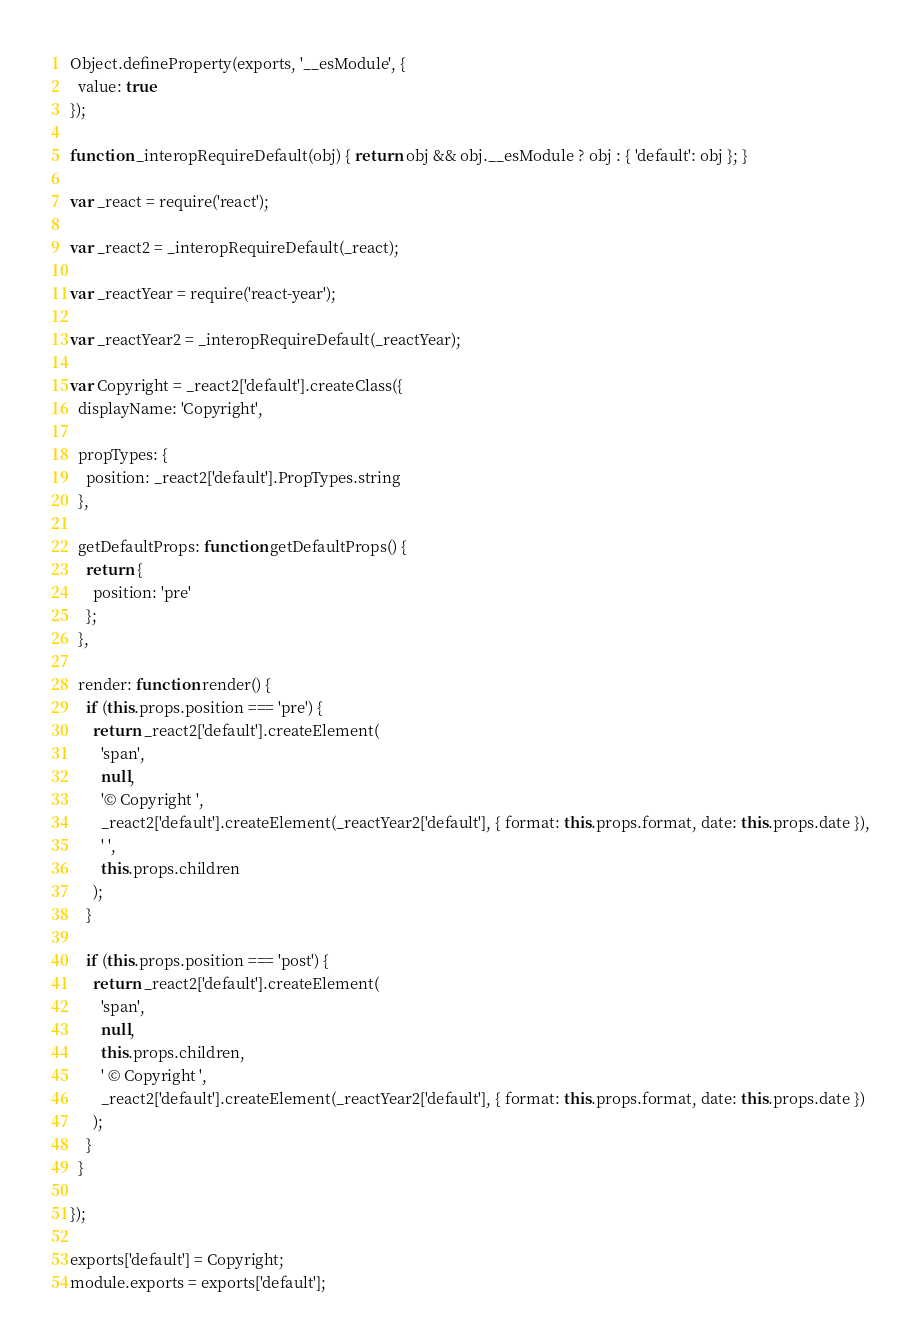Convert code to text. <code><loc_0><loc_0><loc_500><loc_500><_JavaScript_>Object.defineProperty(exports, '__esModule', {
  value: true
});

function _interopRequireDefault(obj) { return obj && obj.__esModule ? obj : { 'default': obj }; }

var _react = require('react');

var _react2 = _interopRequireDefault(_react);

var _reactYear = require('react-year');

var _reactYear2 = _interopRequireDefault(_reactYear);

var Copyright = _react2['default'].createClass({
  displayName: 'Copyright',

  propTypes: {
    position: _react2['default'].PropTypes.string
  },

  getDefaultProps: function getDefaultProps() {
    return {
      position: 'pre'
    };
  },

  render: function render() {
    if (this.props.position === 'pre') {
      return _react2['default'].createElement(
        'span',
        null,
        '© Copyright ',
        _react2['default'].createElement(_reactYear2['default'], { format: this.props.format, date: this.props.date }),
        ' ',
        this.props.children
      );
    }

    if (this.props.position === 'post') {
      return _react2['default'].createElement(
        'span',
        null,
        this.props.children,
        ' © Copyright ',
        _react2['default'].createElement(_reactYear2['default'], { format: this.props.format, date: this.props.date })
      );
    }
  }

});

exports['default'] = Copyright;
module.exports = exports['default'];</code> 